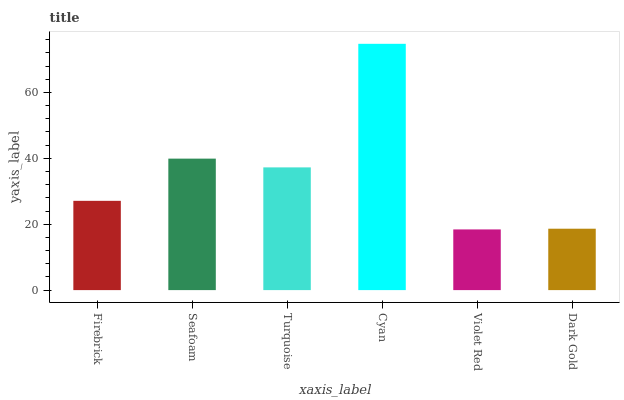Is Violet Red the minimum?
Answer yes or no. Yes. Is Cyan the maximum?
Answer yes or no. Yes. Is Seafoam the minimum?
Answer yes or no. No. Is Seafoam the maximum?
Answer yes or no. No. Is Seafoam greater than Firebrick?
Answer yes or no. Yes. Is Firebrick less than Seafoam?
Answer yes or no. Yes. Is Firebrick greater than Seafoam?
Answer yes or no. No. Is Seafoam less than Firebrick?
Answer yes or no. No. Is Turquoise the high median?
Answer yes or no. Yes. Is Firebrick the low median?
Answer yes or no. Yes. Is Violet Red the high median?
Answer yes or no. No. Is Dark Gold the low median?
Answer yes or no. No. 